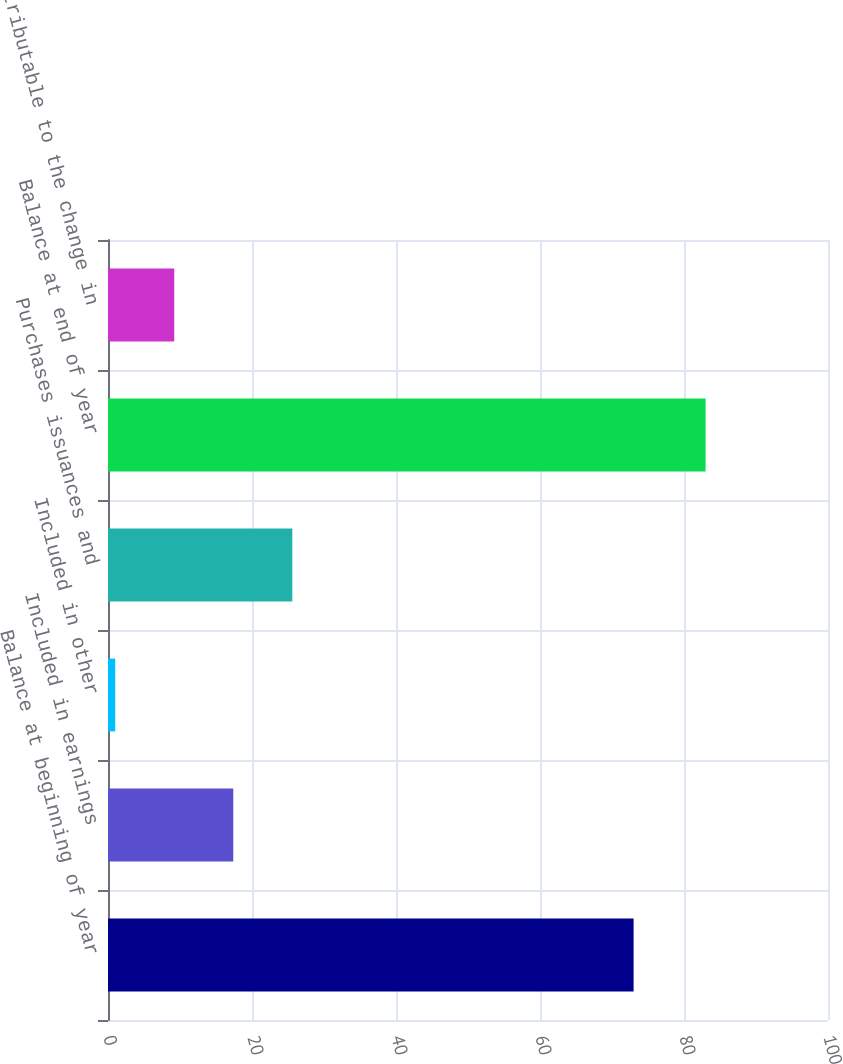Convert chart. <chart><loc_0><loc_0><loc_500><loc_500><bar_chart><fcel>Balance at beginning of year<fcel>Included in earnings<fcel>Included in other<fcel>Purchases issuances and<fcel>Balance at end of year<fcel>attributable to the change in<nl><fcel>73<fcel>17.4<fcel>1<fcel>25.6<fcel>83<fcel>9.2<nl></chart> 